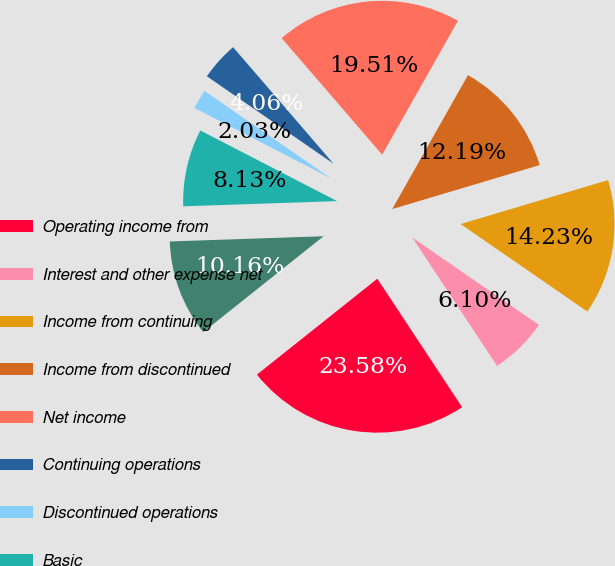Convert chart. <chart><loc_0><loc_0><loc_500><loc_500><pie_chart><fcel>Operating income from<fcel>Interest and other expense net<fcel>Income from continuing<fcel>Income from discontinued<fcel>Net income<fcel>Continuing operations<fcel>Discontinued operations<fcel>Basic<fcel>Diluted<nl><fcel>23.58%<fcel>6.1%<fcel>14.23%<fcel>12.19%<fcel>19.51%<fcel>4.06%<fcel>2.03%<fcel>8.13%<fcel>10.16%<nl></chart> 